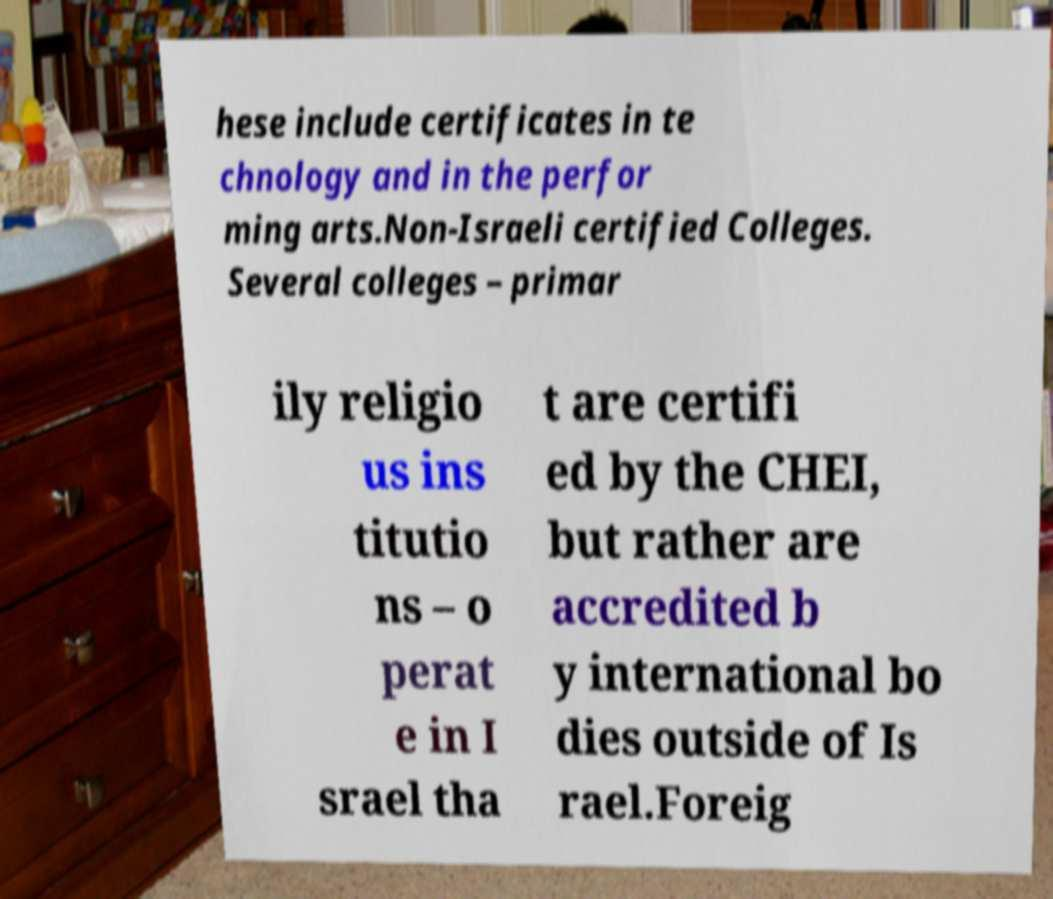For documentation purposes, I need the text within this image transcribed. Could you provide that? hese include certificates in te chnology and in the perfor ming arts.Non-Israeli certified Colleges. Several colleges – primar ily religio us ins titutio ns – o perat e in I srael tha t are certifi ed by the CHEI, but rather are accredited b y international bo dies outside of Is rael.Foreig 